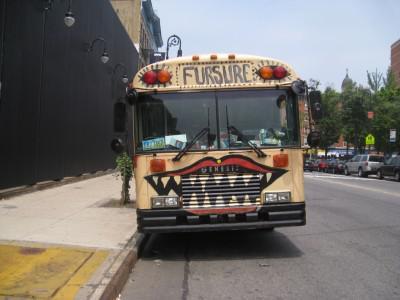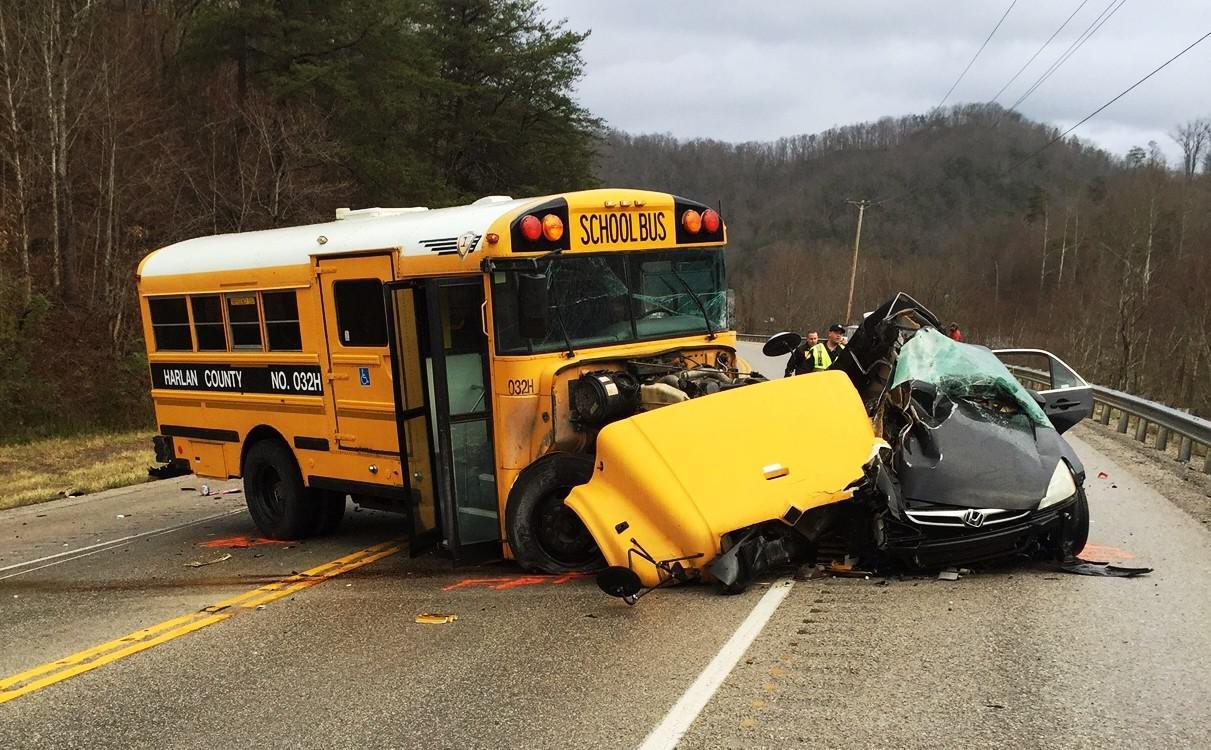The first image is the image on the left, the second image is the image on the right. Considering the images on both sides, is "One image shows a bus decorated with some type of 'artwork', and the other image shows a bus with severe impact damage on its front end." valid? Answer yes or no. Yes. The first image is the image on the left, the second image is the image on the right. For the images shown, is this caption "In one image there is a single schoolbus that has been involved in an accident and is wrecked in the center of the image." true? Answer yes or no. Yes. 